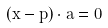Convert formula to latex. <formula><loc_0><loc_0><loc_500><loc_500>( x - p ) \cdot a = 0</formula> 